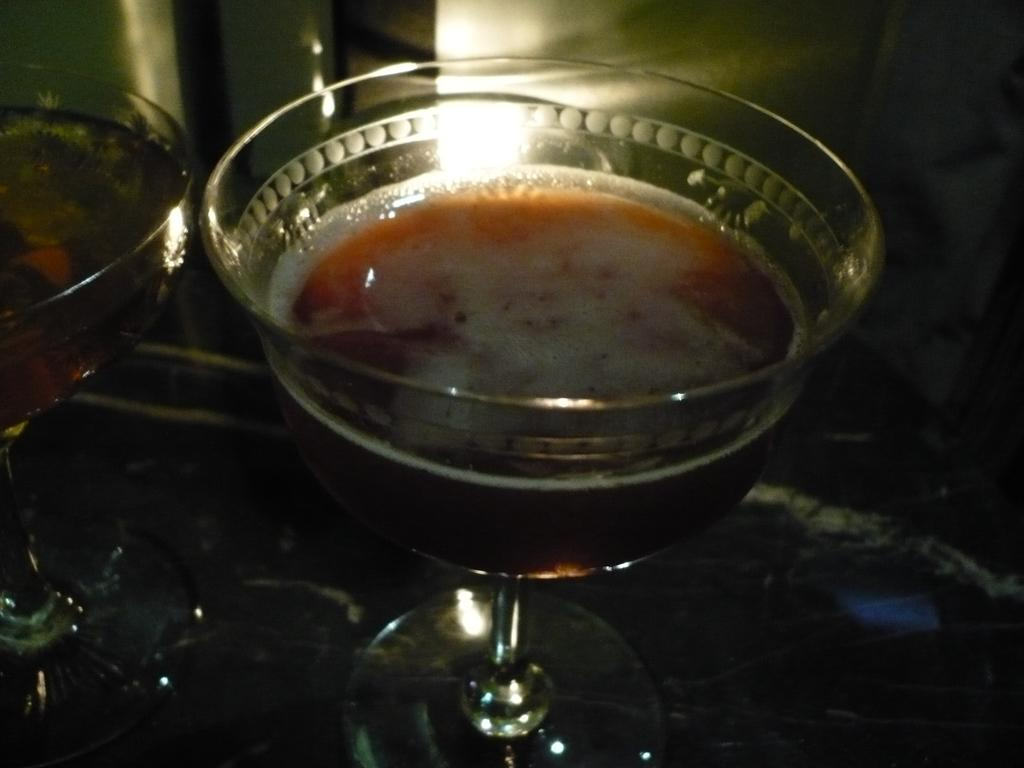What objects are present in the image that have stands? There are bowls with stands in the image. What is inside the bowls? The bowls contain soup. How many rings does the porter wear in the image? There is no porter or rings present in the image. What type of record is being played in the background of the image? There is no record being played in the image. 